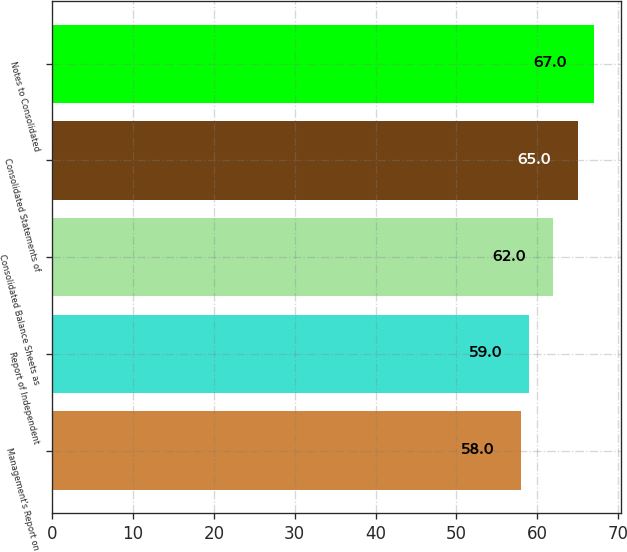Convert chart. <chart><loc_0><loc_0><loc_500><loc_500><bar_chart><fcel>Management's Report on<fcel>Report of Independent<fcel>Consolidated Balance Sheets as<fcel>Consolidated Statements of<fcel>Notes to Consolidated<nl><fcel>58<fcel>59<fcel>62<fcel>65<fcel>67<nl></chart> 